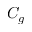Convert formula to latex. <formula><loc_0><loc_0><loc_500><loc_500>C _ { g }</formula> 